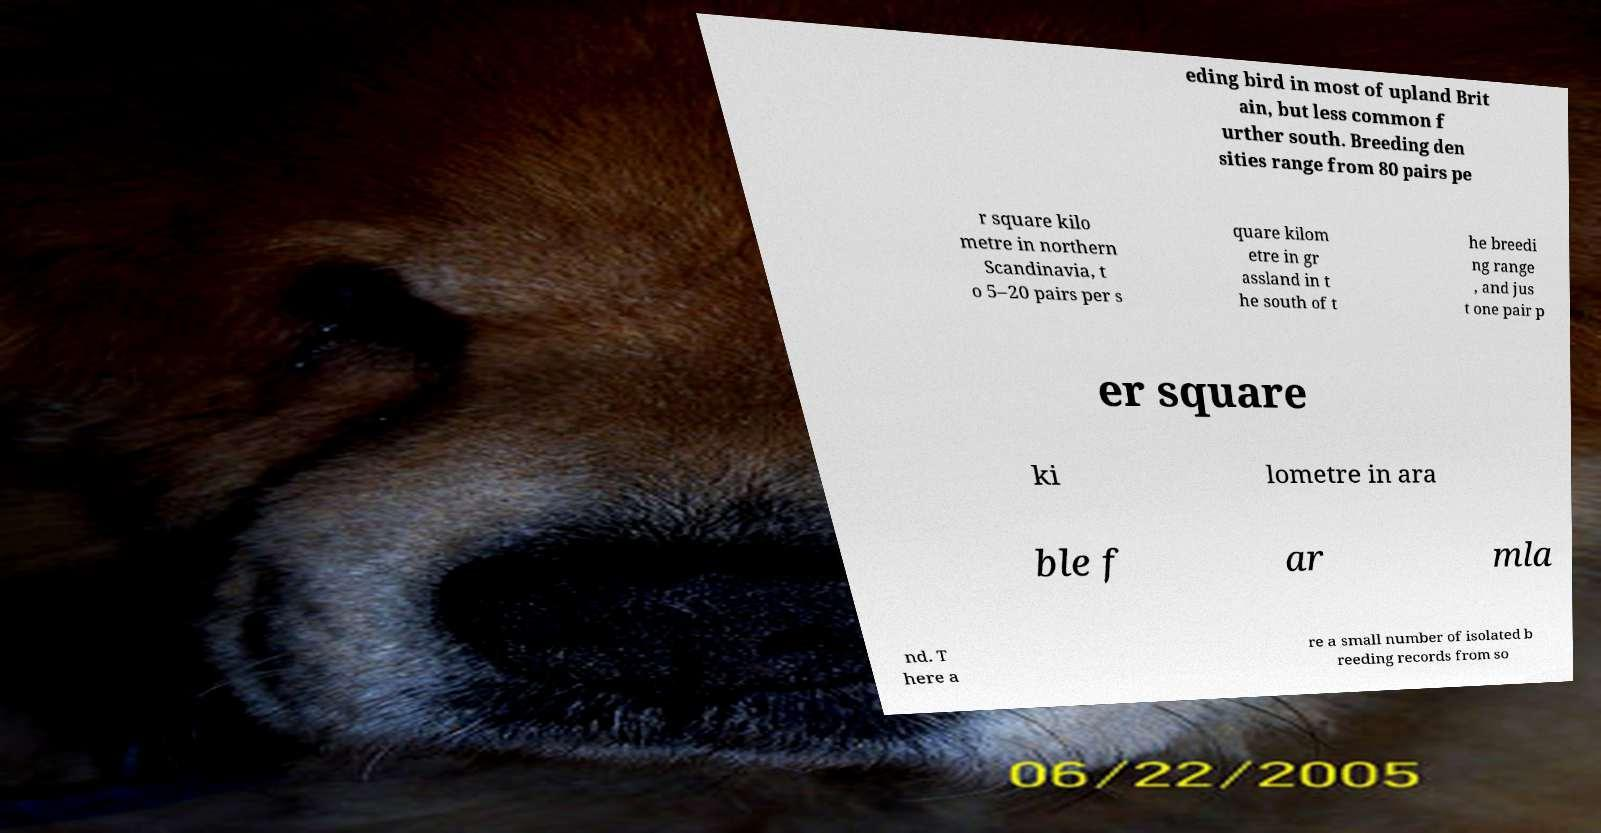There's text embedded in this image that I need extracted. Can you transcribe it verbatim? eding bird in most of upland Brit ain, but less common f urther south. Breeding den sities range from 80 pairs pe r square kilo metre in northern Scandinavia, t o 5–20 pairs per s quare kilom etre in gr assland in t he south of t he breedi ng range , and jus t one pair p er square ki lometre in ara ble f ar mla nd. T here a re a small number of isolated b reeding records from so 